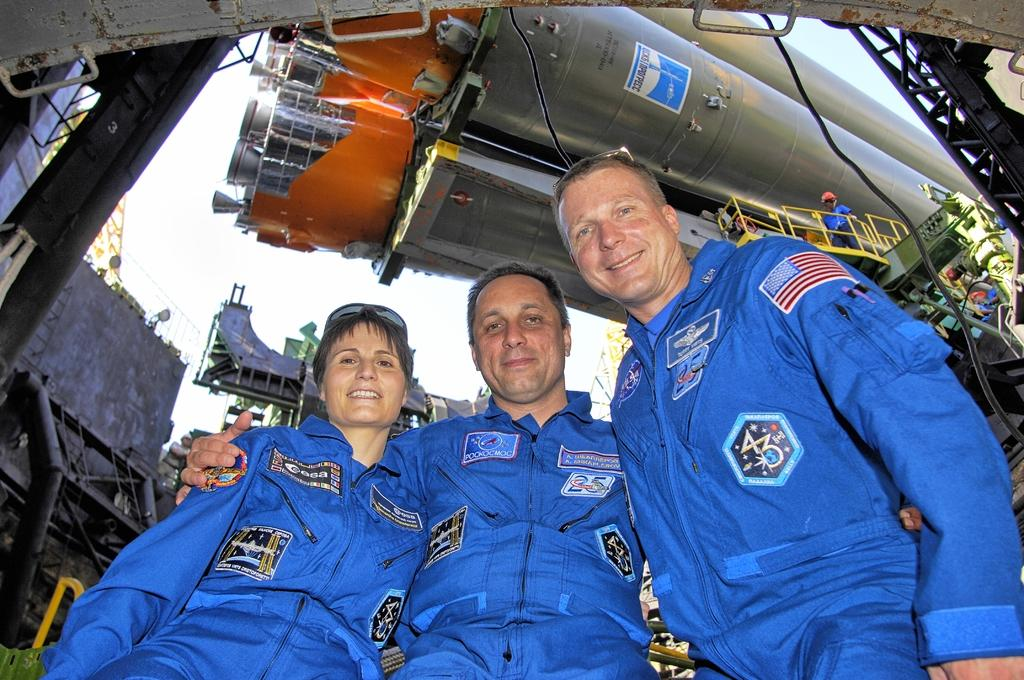How many people are in the image? There are three persons in the image. What are the persons wearing? The three persons are wearing the same dress. What can be seen behind the persons? There is machinery visible behind the persons. What position are the persons in? The persons are standing. What is visible at the top of the image? The sky is visible at the top of the image. How many goats are present in the image? There are no goats present in the image. What is the mass of the machinery visible behind the persons? The mass of the machinery cannot be determined from the image alone. 